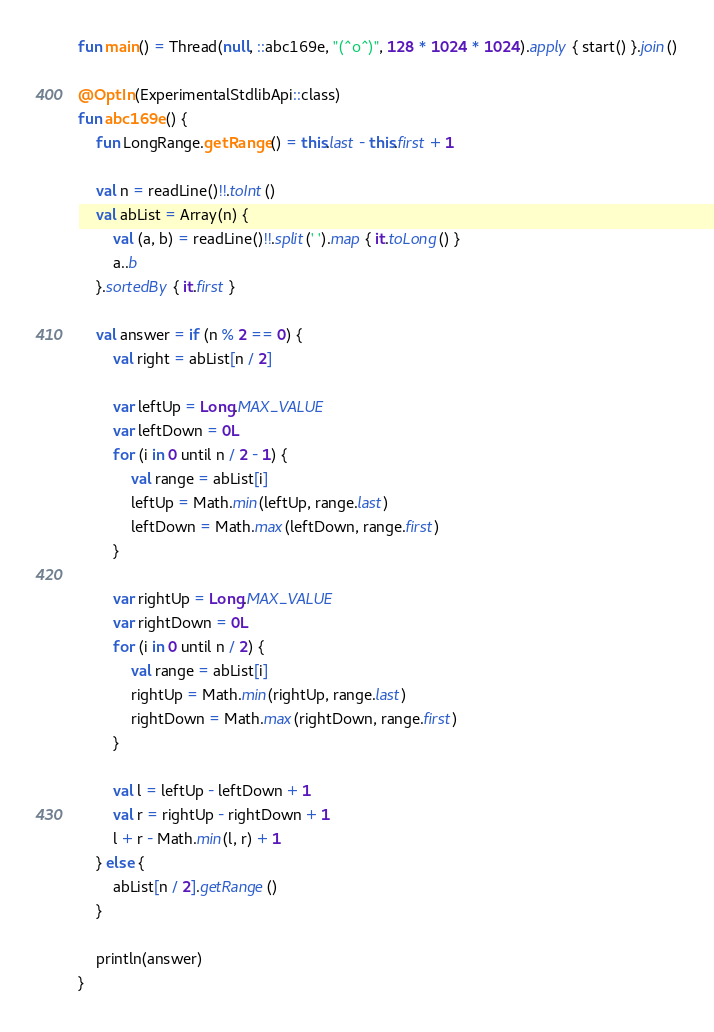<code> <loc_0><loc_0><loc_500><loc_500><_Kotlin_>fun main() = Thread(null, ::abc169e, "(^o^)", 128 * 1024 * 1024).apply { start() }.join()

@OptIn(ExperimentalStdlibApi::class)
fun abc169e() {
    fun LongRange.getRange() = this.last - this.first + 1

    val n = readLine()!!.toInt()
    val abList = Array(n) {
        val (a, b) = readLine()!!.split(' ').map { it.toLong() }
        a..b
    }.sortedBy { it.first }

    val answer = if (n % 2 == 0) {
        val right = abList[n / 2]

        var leftUp = Long.MAX_VALUE
        var leftDown = 0L
        for (i in 0 until n / 2 - 1) {
            val range = abList[i]
            leftUp = Math.min(leftUp, range.last)
            leftDown = Math.max(leftDown, range.first)
        }

        var rightUp = Long.MAX_VALUE
        var rightDown = 0L
        for (i in 0 until n / 2) {
            val range = abList[i]
            rightUp = Math.min(rightUp, range.last)
            rightDown = Math.max(rightDown, range.first)
        }

        val l = leftUp - leftDown + 1
        val r = rightUp - rightDown + 1
        l + r - Math.min(l, r) + 1
    } else {
        abList[n / 2].getRange()
    }

    println(answer)
}
</code> 